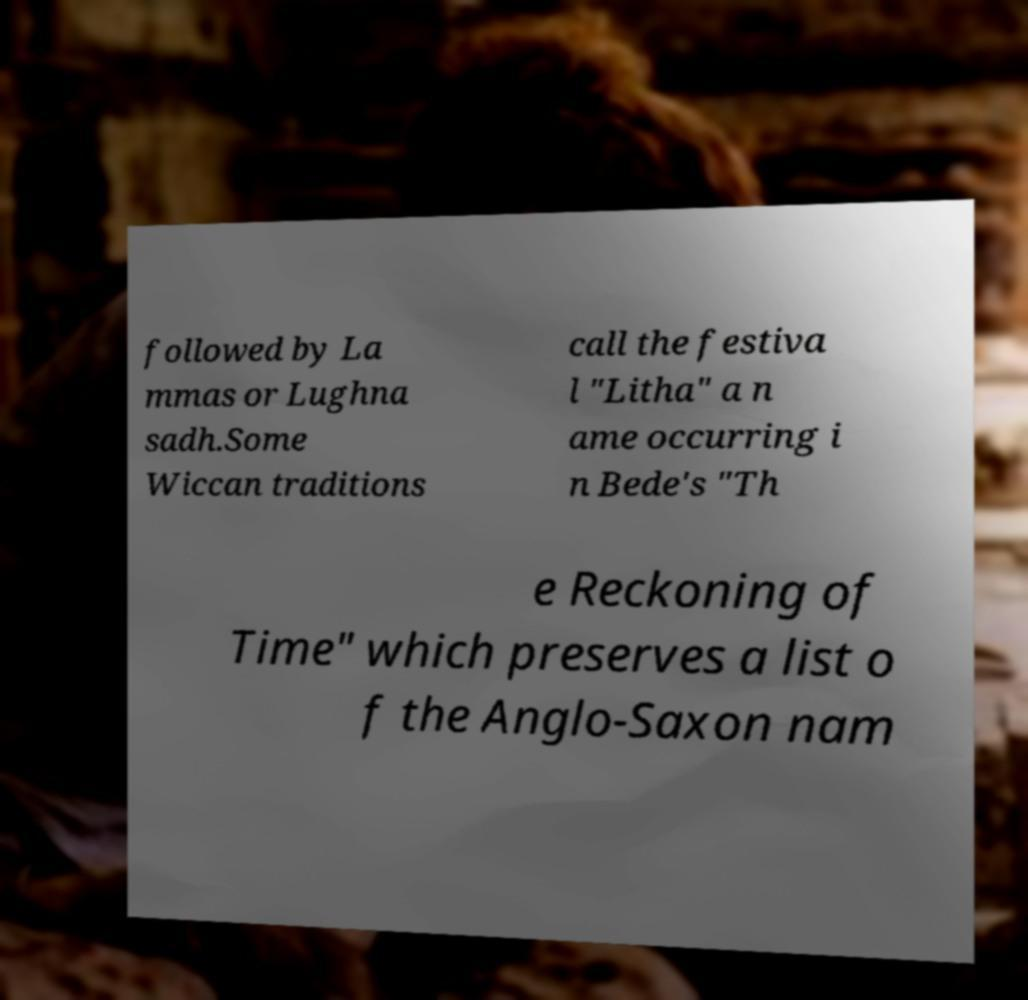What messages or text are displayed in this image? I need them in a readable, typed format. followed by La mmas or Lughna sadh.Some Wiccan traditions call the festiva l "Litha" a n ame occurring i n Bede's "Th e Reckoning of Time" which preserves a list o f the Anglo-Saxon nam 